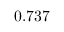Convert formula to latex. <formula><loc_0><loc_0><loc_500><loc_500>0 . 7 3 7</formula> 